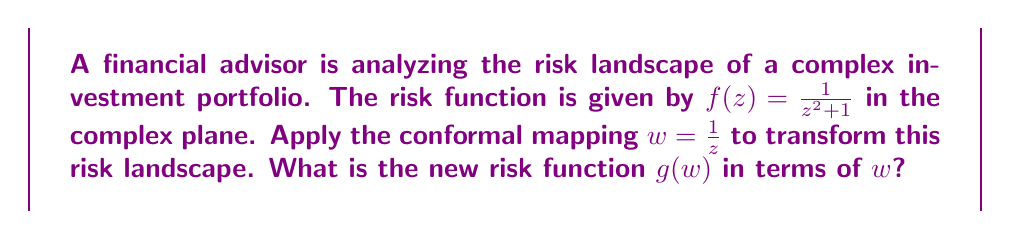Give your solution to this math problem. To solve this problem, we'll follow these steps:

1) We start with the original risk function:
   $$f(z) = \frac{1}{z^2 + 1}$$

2) We're applying the conformal mapping $w = \frac{1}{z}$. This means we need to express $z$ in terms of $w$:
   $$z = \frac{1}{w}$$

3) Now, we need to substitute this expression for $z$ into our original function $f(z)$:
   $$g(w) = f(\frac{1}{w}) = \frac{1}{(\frac{1}{w})^2 + 1}$$

4) Let's simplify the denominator:
   $$g(w) = \frac{1}{\frac{1}{w^2} + 1}$$

5) To get a common denominator, we multiply both terms in the denominator by $w^2$:
   $$g(w) = \frac{1}{\frac{w^2}{w^2} + \frac{1}{w^2}}$$

6) Simplify:
   $$g(w) = \frac{1}{\frac{w^2 + 1}{w^2}}$$

7) Invert the fraction:
   $$g(w) = \frac{w^2}{w^2 + 1}$$

This is our final transformed risk function in terms of $w$.
Answer: $$g(w) = \frac{w^2}{w^2 + 1}$$ 